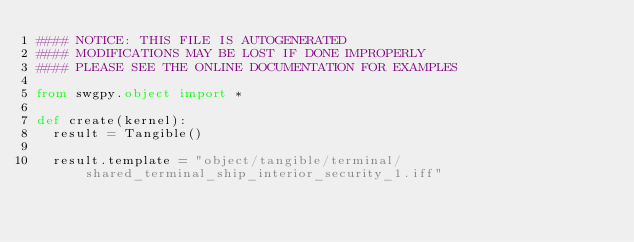Convert code to text. <code><loc_0><loc_0><loc_500><loc_500><_Python_>#### NOTICE: THIS FILE IS AUTOGENERATED
#### MODIFICATIONS MAY BE LOST IF DONE IMPROPERLY
#### PLEASE SEE THE ONLINE DOCUMENTATION FOR EXAMPLES

from swgpy.object import *	

def create(kernel):
	result = Tangible()

	result.template = "object/tangible/terminal/shared_terminal_ship_interior_security_1.iff"</code> 